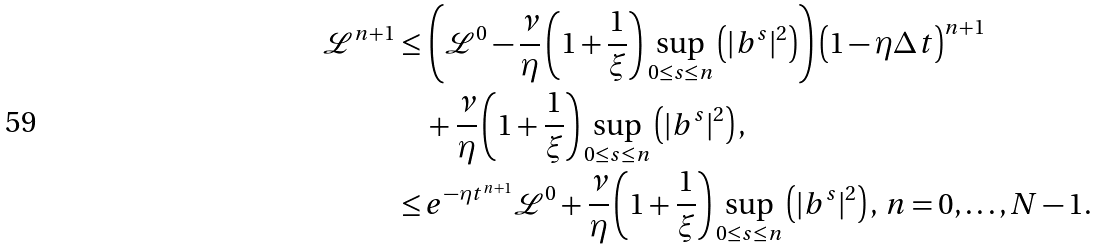<formula> <loc_0><loc_0><loc_500><loc_500>\mathcal { L } ^ { n + 1 } \leq & \, \left ( \mathcal { L } ^ { 0 } - \frac { \nu } { \eta } \left ( 1 + \frac { 1 } { \xi } \right ) \sup _ { 0 \leq s \leq n } \left ( | b ^ { s } | ^ { 2 } \right ) \right ) \left ( 1 - \eta { \Delta t } \right ) ^ { n + 1 } \\ & \, + \frac { \nu } { \eta } \left ( 1 + \frac { 1 } { \xi } \right ) \sup _ { 0 \leq s \leq n } \left ( | b ^ { s } | ^ { 2 } \right ) , \\ \leq & \, e ^ { - { \eta } { t } ^ { n + 1 } } \mathcal { L } ^ { 0 } + \frac { \nu } { \eta } \left ( 1 + \frac { 1 } { \xi } \right ) \sup _ { 0 \leq s \leq n } \left ( | b ^ { s } | ^ { 2 } \right ) , \, n = 0 , \dots , N - 1 .</formula> 